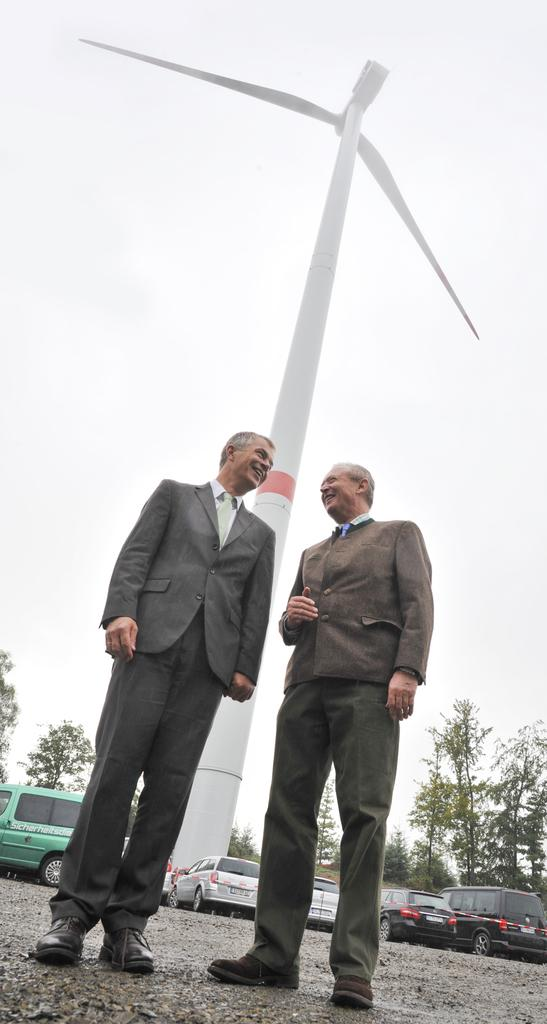How many people are standing in the image? There are two persons standing in the image. What can be seen in the background of the image? There are vehicles, a wind fan, trees, and the sky visible in the background. What type of mask is the person on the left wearing in the image? There is no mask visible on either person in the image. 